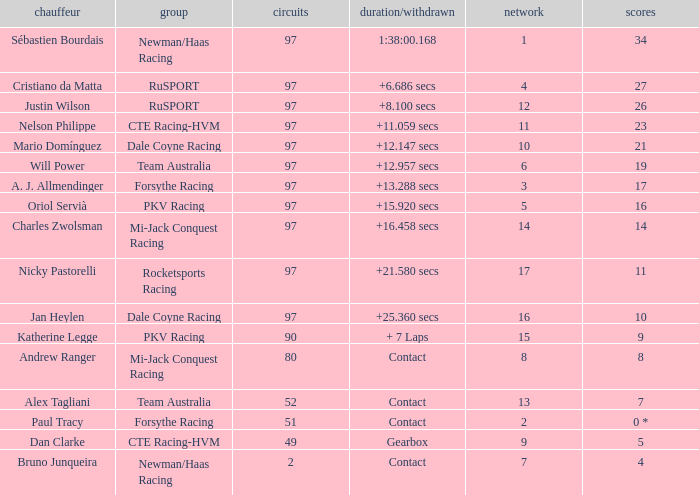What team does jan heylen race for? Dale Coyne Racing. Would you mind parsing the complete table? {'header': ['chauffeur', 'group', 'circuits', 'duration/withdrawn', 'network', 'scores'], 'rows': [['Sébastien Bourdais', 'Newman/Haas Racing', '97', '1:38:00.168', '1', '34'], ['Cristiano da Matta', 'RuSPORT', '97', '+6.686 secs', '4', '27'], ['Justin Wilson', 'RuSPORT', '97', '+8.100 secs', '12', '26'], ['Nelson Philippe', 'CTE Racing-HVM', '97', '+11.059 secs', '11', '23'], ['Mario Domínguez', 'Dale Coyne Racing', '97', '+12.147 secs', '10', '21'], ['Will Power', 'Team Australia', '97', '+12.957 secs', '6', '19'], ['A. J. Allmendinger', 'Forsythe Racing', '97', '+13.288 secs', '3', '17'], ['Oriol Servià', 'PKV Racing', '97', '+15.920 secs', '5', '16'], ['Charles Zwolsman', 'Mi-Jack Conquest Racing', '97', '+16.458 secs', '14', '14'], ['Nicky Pastorelli', 'Rocketsports Racing', '97', '+21.580 secs', '17', '11'], ['Jan Heylen', 'Dale Coyne Racing', '97', '+25.360 secs', '16', '10'], ['Katherine Legge', 'PKV Racing', '90', '+ 7 Laps', '15', '9'], ['Andrew Ranger', 'Mi-Jack Conquest Racing', '80', 'Contact', '8', '8'], ['Alex Tagliani', 'Team Australia', '52', 'Contact', '13', '7'], ['Paul Tracy', 'Forsythe Racing', '51', 'Contact', '2', '0 *'], ['Dan Clarke', 'CTE Racing-HVM', '49', 'Gearbox', '9', '5'], ['Bruno Junqueira', 'Newman/Haas Racing', '2', 'Contact', '7', '4']]} 